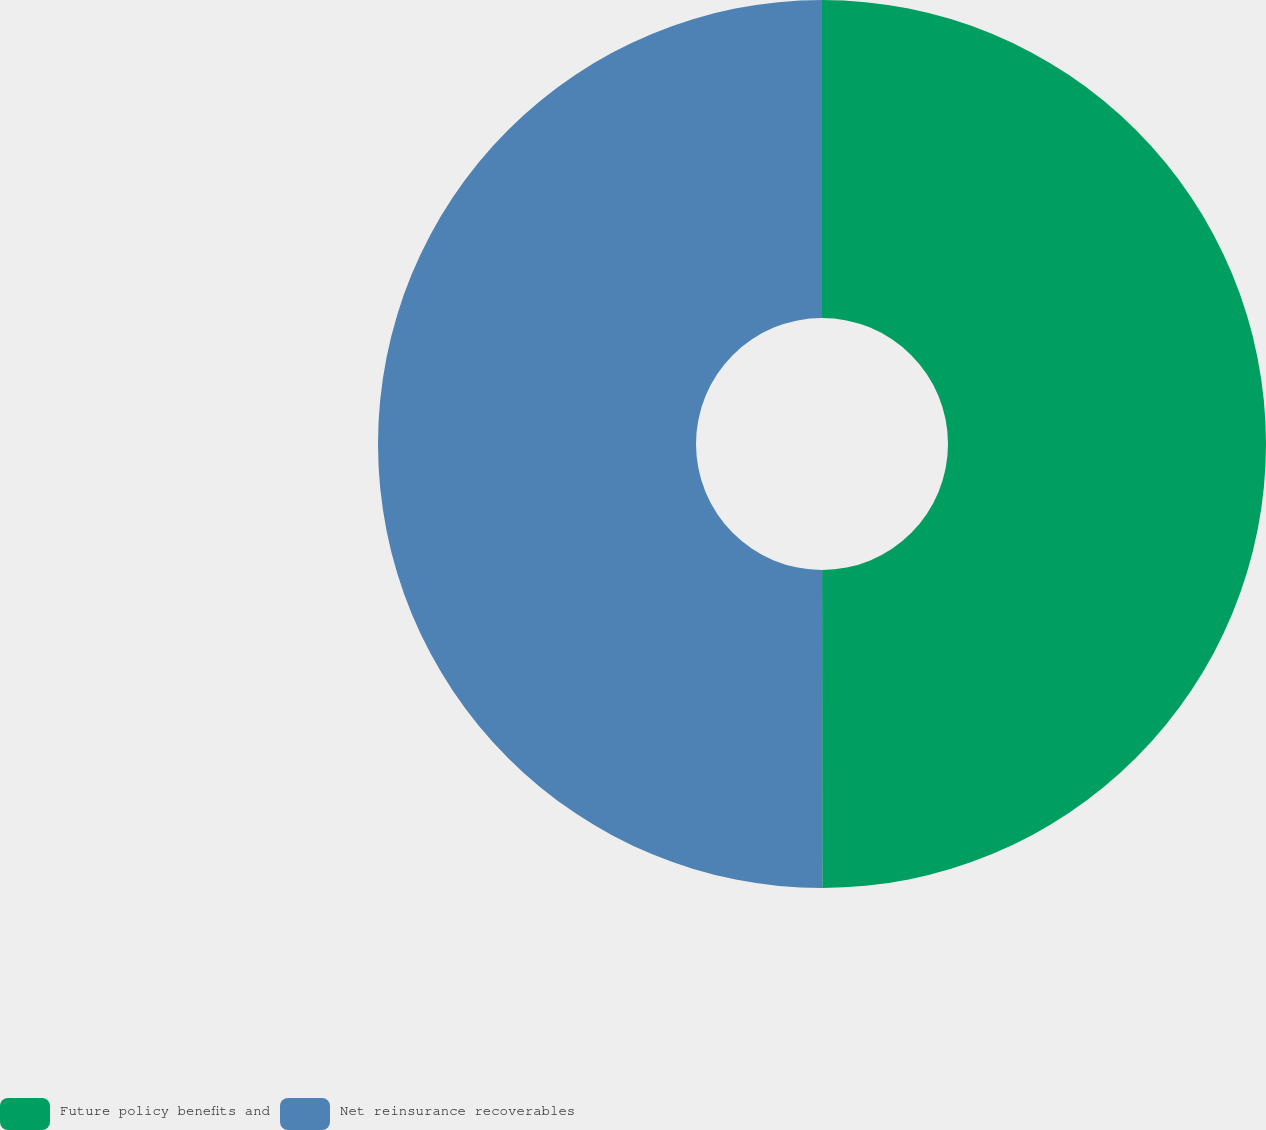Convert chart. <chart><loc_0><loc_0><loc_500><loc_500><pie_chart><fcel>Future policy benefits and<fcel>Net reinsurance recoverables<nl><fcel>49.99%<fcel>50.01%<nl></chart> 